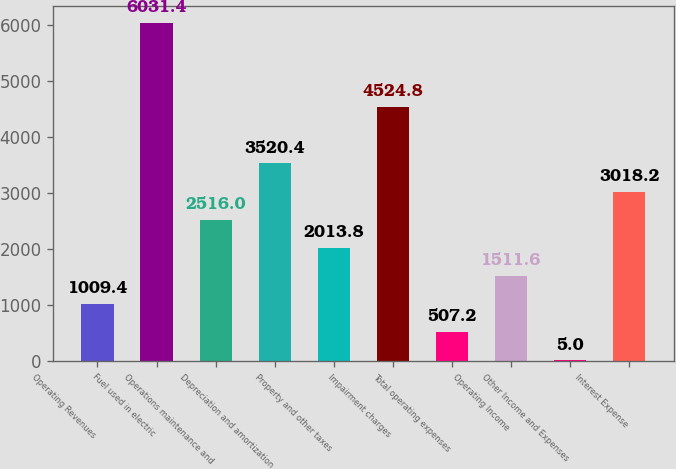<chart> <loc_0><loc_0><loc_500><loc_500><bar_chart><fcel>Operating Revenues<fcel>Fuel used in electric<fcel>Operations maintenance and<fcel>Depreciation and amortization<fcel>Property and other taxes<fcel>Impairment charges<fcel>Total operating expenses<fcel>Operating Income<fcel>Other Income and Expenses<fcel>Interest Expense<nl><fcel>1009.4<fcel>6031.4<fcel>2516<fcel>3520.4<fcel>2013.8<fcel>4524.8<fcel>507.2<fcel>1511.6<fcel>5<fcel>3018.2<nl></chart> 